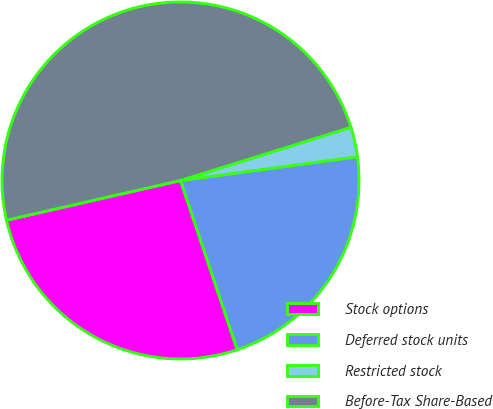Convert chart to OTSL. <chart><loc_0><loc_0><loc_500><loc_500><pie_chart><fcel>Stock options<fcel>Deferred stock units<fcel>Restricted stock<fcel>Before-Tax Share-Based<nl><fcel>26.58%<fcel>21.97%<fcel>2.69%<fcel>48.76%<nl></chart> 